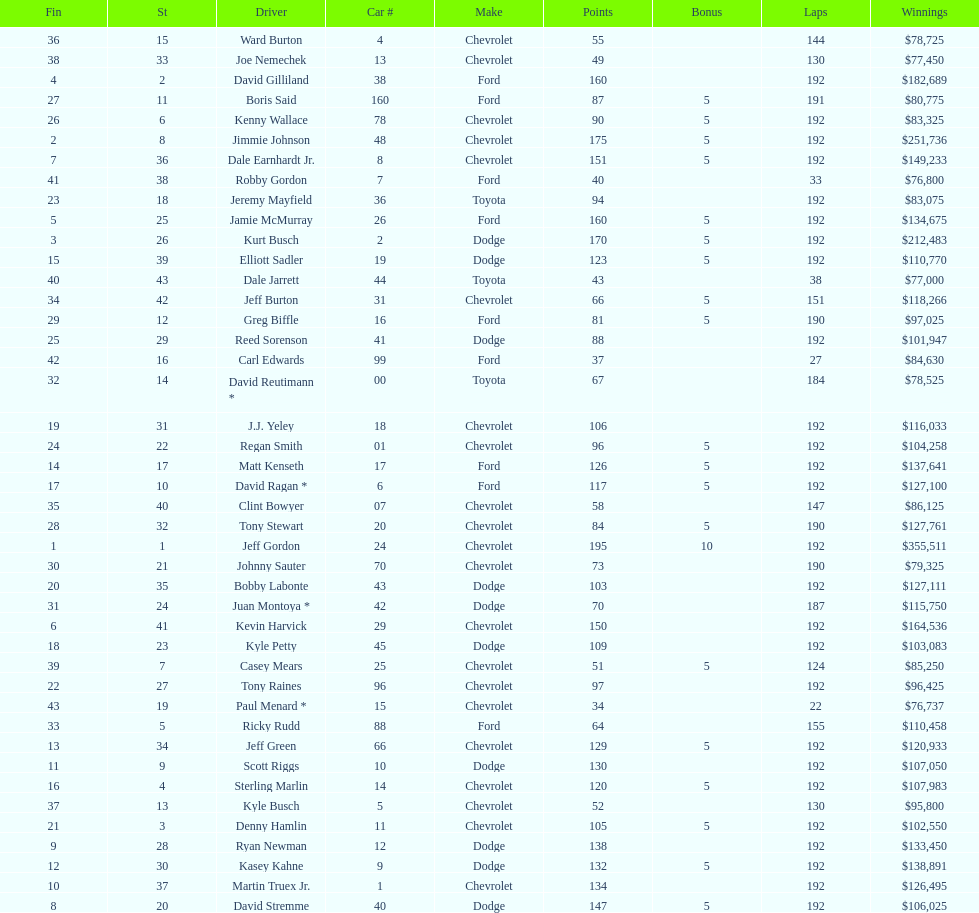What driver earned the least amount of winnings? Paul Menard *. 